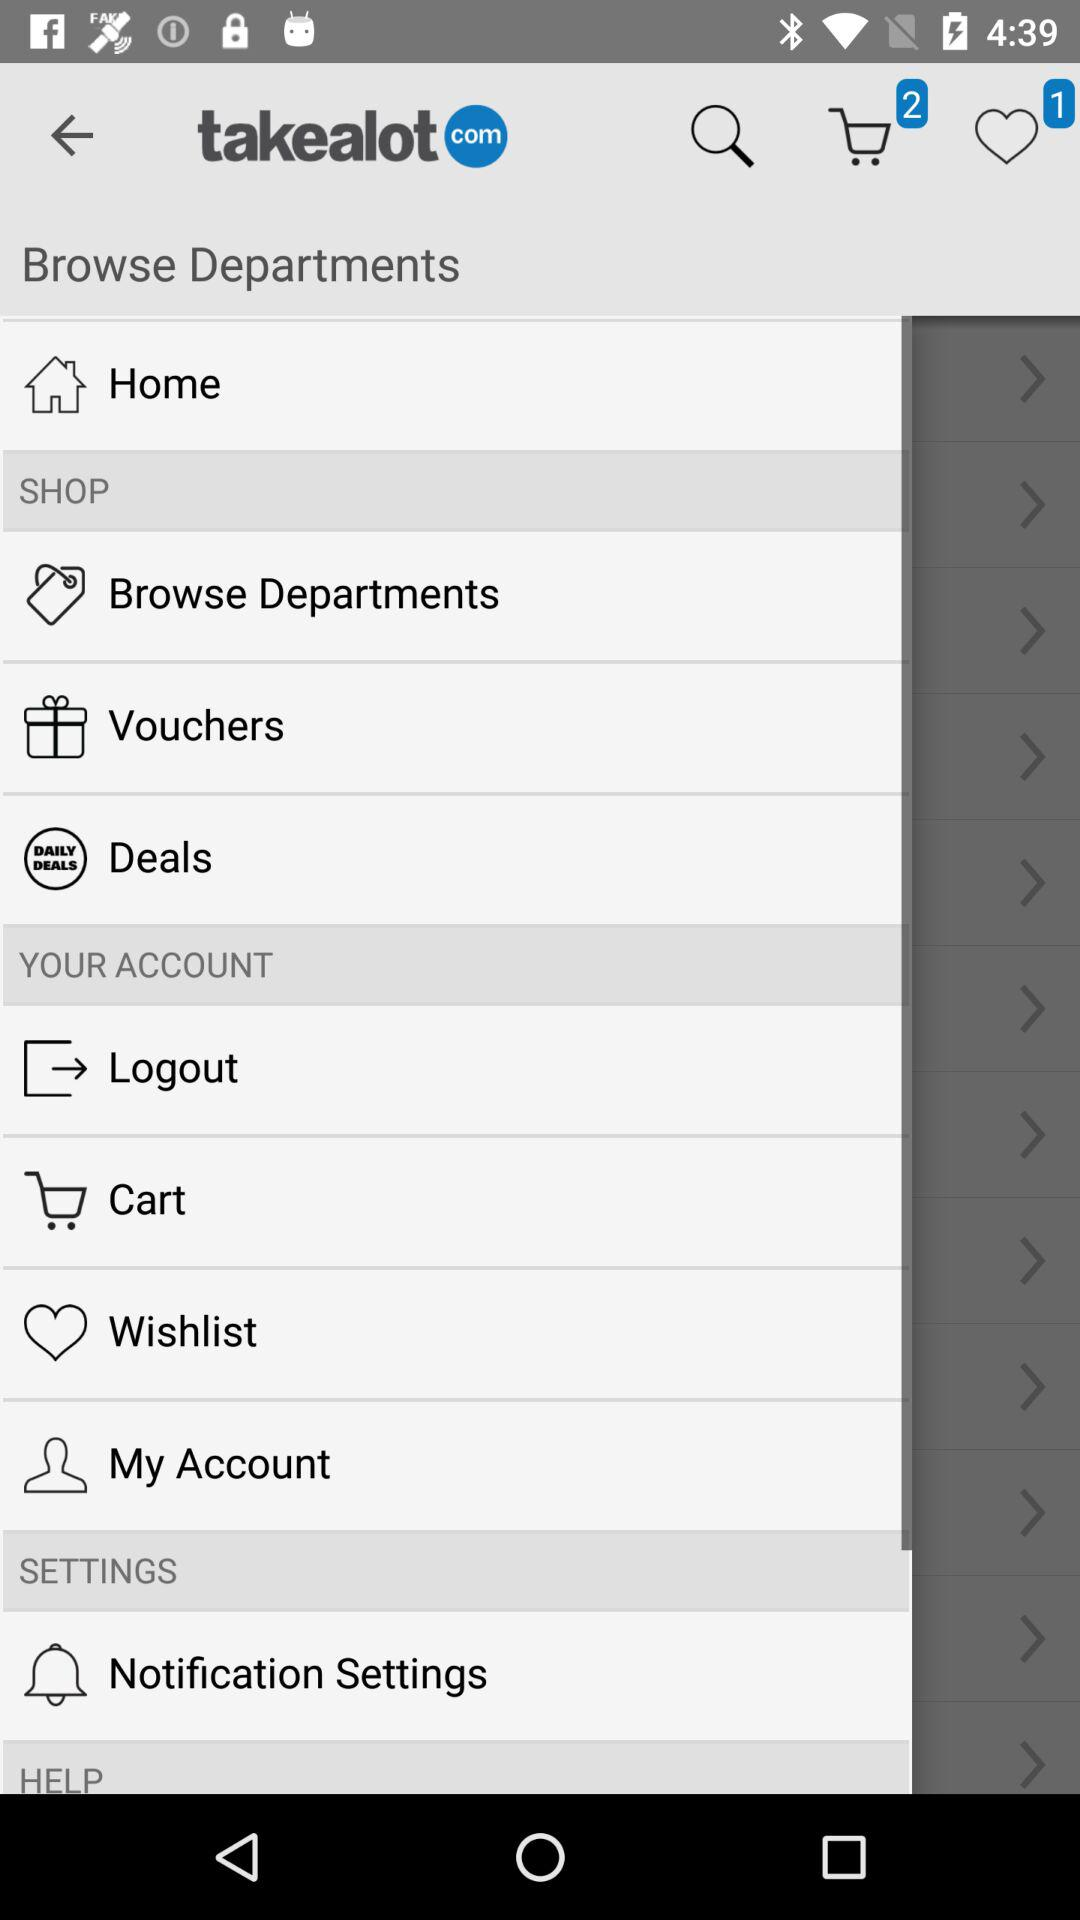How many notifications are there in "Notification Settings"?
When the provided information is insufficient, respond with <no answer>. <no answer> 